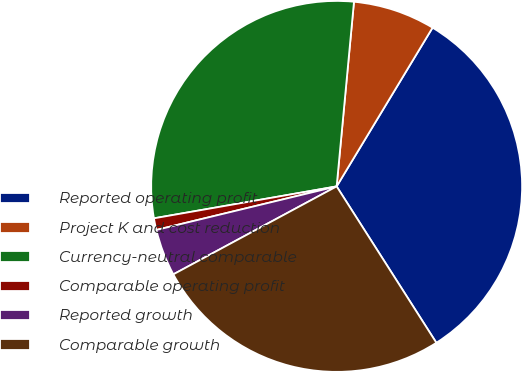<chart> <loc_0><loc_0><loc_500><loc_500><pie_chart><fcel>Reported operating profit<fcel>Project K and cost reduction<fcel>Currency-neutral comparable<fcel>Comparable operating profit<fcel>Reported growth<fcel>Comparable growth<nl><fcel>32.31%<fcel>7.16%<fcel>29.24%<fcel>1.02%<fcel>4.09%<fcel>26.17%<nl></chart> 